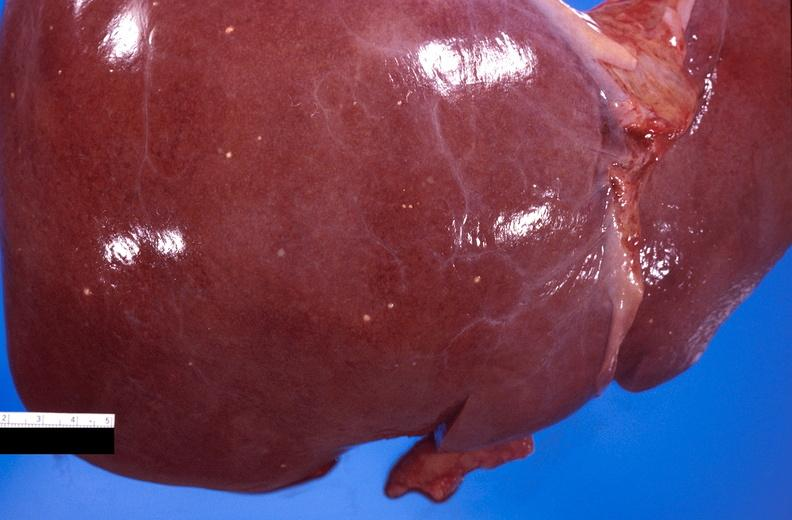what is present?
Answer the question using a single word or phrase. Hepatobiliary 